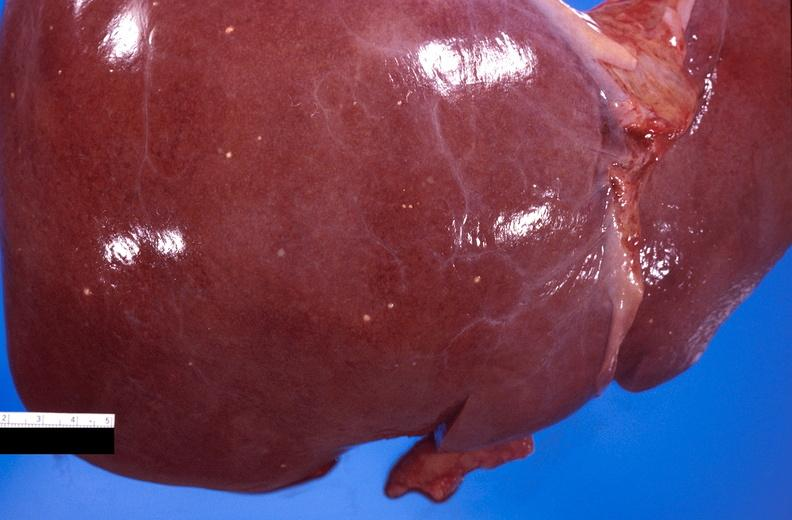what is present?
Answer the question using a single word or phrase. Hepatobiliary 